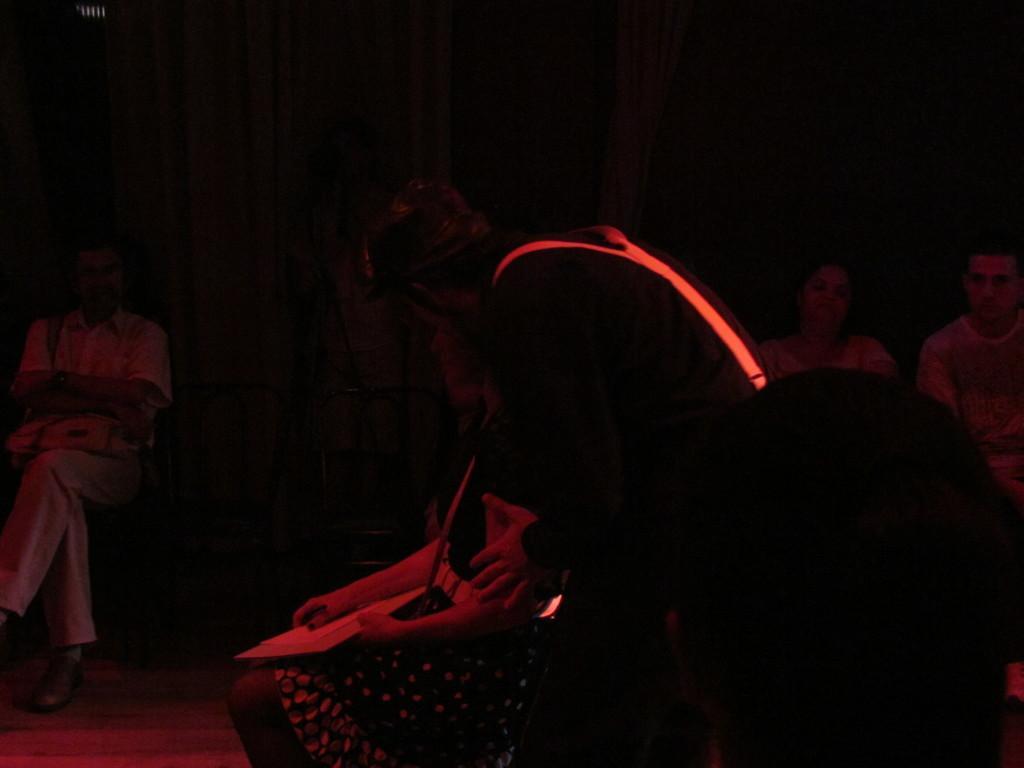Describe this image in one or two sentences. In this image I can see a group of people are sitting on the chairs, door and wall. This image is taken may be during night. 